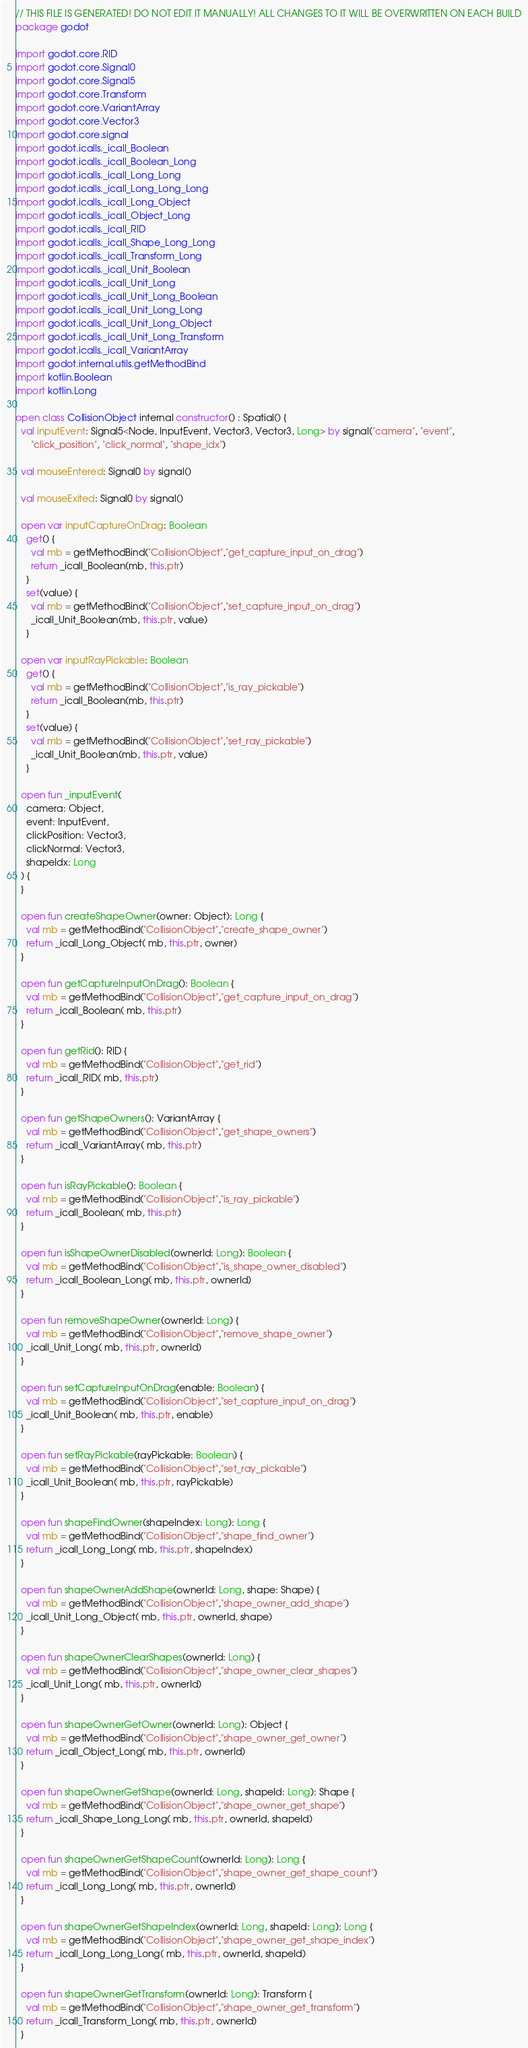Convert code to text. <code><loc_0><loc_0><loc_500><loc_500><_Kotlin_>// THIS FILE IS GENERATED! DO NOT EDIT IT MANUALLY! ALL CHANGES TO IT WILL BE OVERWRITTEN ON EACH BUILD
package godot

import godot.core.RID
import godot.core.Signal0
import godot.core.Signal5
import godot.core.Transform
import godot.core.VariantArray
import godot.core.Vector3
import godot.core.signal
import godot.icalls._icall_Boolean
import godot.icalls._icall_Boolean_Long
import godot.icalls._icall_Long_Long
import godot.icalls._icall_Long_Long_Long
import godot.icalls._icall_Long_Object
import godot.icalls._icall_Object_Long
import godot.icalls._icall_RID
import godot.icalls._icall_Shape_Long_Long
import godot.icalls._icall_Transform_Long
import godot.icalls._icall_Unit_Boolean
import godot.icalls._icall_Unit_Long
import godot.icalls._icall_Unit_Long_Boolean
import godot.icalls._icall_Unit_Long_Long
import godot.icalls._icall_Unit_Long_Object
import godot.icalls._icall_Unit_Long_Transform
import godot.icalls._icall_VariantArray
import godot.internal.utils.getMethodBind
import kotlin.Boolean
import kotlin.Long

open class CollisionObject internal constructor() : Spatial() {
  val inputEvent: Signal5<Node, InputEvent, Vector3, Vector3, Long> by signal("camera", "event",
      "click_position", "click_normal", "shape_idx")

  val mouseEntered: Signal0 by signal()

  val mouseExited: Signal0 by signal()

  open var inputCaptureOnDrag: Boolean
    get() {
      val mb = getMethodBind("CollisionObject","get_capture_input_on_drag")
      return _icall_Boolean(mb, this.ptr)
    }
    set(value) {
      val mb = getMethodBind("CollisionObject","set_capture_input_on_drag")
      _icall_Unit_Boolean(mb, this.ptr, value)
    }

  open var inputRayPickable: Boolean
    get() {
      val mb = getMethodBind("CollisionObject","is_ray_pickable")
      return _icall_Boolean(mb, this.ptr)
    }
    set(value) {
      val mb = getMethodBind("CollisionObject","set_ray_pickable")
      _icall_Unit_Boolean(mb, this.ptr, value)
    }

  open fun _inputEvent(
    camera: Object,
    event: InputEvent,
    clickPosition: Vector3,
    clickNormal: Vector3,
    shapeIdx: Long
  ) {
  }

  open fun createShapeOwner(owner: Object): Long {
    val mb = getMethodBind("CollisionObject","create_shape_owner")
    return _icall_Long_Object( mb, this.ptr, owner)
  }

  open fun getCaptureInputOnDrag(): Boolean {
    val mb = getMethodBind("CollisionObject","get_capture_input_on_drag")
    return _icall_Boolean( mb, this.ptr)
  }

  open fun getRid(): RID {
    val mb = getMethodBind("CollisionObject","get_rid")
    return _icall_RID( mb, this.ptr)
  }

  open fun getShapeOwners(): VariantArray {
    val mb = getMethodBind("CollisionObject","get_shape_owners")
    return _icall_VariantArray( mb, this.ptr)
  }

  open fun isRayPickable(): Boolean {
    val mb = getMethodBind("CollisionObject","is_ray_pickable")
    return _icall_Boolean( mb, this.ptr)
  }

  open fun isShapeOwnerDisabled(ownerId: Long): Boolean {
    val mb = getMethodBind("CollisionObject","is_shape_owner_disabled")
    return _icall_Boolean_Long( mb, this.ptr, ownerId)
  }

  open fun removeShapeOwner(ownerId: Long) {
    val mb = getMethodBind("CollisionObject","remove_shape_owner")
    _icall_Unit_Long( mb, this.ptr, ownerId)
  }

  open fun setCaptureInputOnDrag(enable: Boolean) {
    val mb = getMethodBind("CollisionObject","set_capture_input_on_drag")
    _icall_Unit_Boolean( mb, this.ptr, enable)
  }

  open fun setRayPickable(rayPickable: Boolean) {
    val mb = getMethodBind("CollisionObject","set_ray_pickable")
    _icall_Unit_Boolean( mb, this.ptr, rayPickable)
  }

  open fun shapeFindOwner(shapeIndex: Long): Long {
    val mb = getMethodBind("CollisionObject","shape_find_owner")
    return _icall_Long_Long( mb, this.ptr, shapeIndex)
  }

  open fun shapeOwnerAddShape(ownerId: Long, shape: Shape) {
    val mb = getMethodBind("CollisionObject","shape_owner_add_shape")
    _icall_Unit_Long_Object( mb, this.ptr, ownerId, shape)
  }

  open fun shapeOwnerClearShapes(ownerId: Long) {
    val mb = getMethodBind("CollisionObject","shape_owner_clear_shapes")
    _icall_Unit_Long( mb, this.ptr, ownerId)
  }

  open fun shapeOwnerGetOwner(ownerId: Long): Object {
    val mb = getMethodBind("CollisionObject","shape_owner_get_owner")
    return _icall_Object_Long( mb, this.ptr, ownerId)
  }

  open fun shapeOwnerGetShape(ownerId: Long, shapeId: Long): Shape {
    val mb = getMethodBind("CollisionObject","shape_owner_get_shape")
    return _icall_Shape_Long_Long( mb, this.ptr, ownerId, shapeId)
  }

  open fun shapeOwnerGetShapeCount(ownerId: Long): Long {
    val mb = getMethodBind("CollisionObject","shape_owner_get_shape_count")
    return _icall_Long_Long( mb, this.ptr, ownerId)
  }

  open fun shapeOwnerGetShapeIndex(ownerId: Long, shapeId: Long): Long {
    val mb = getMethodBind("CollisionObject","shape_owner_get_shape_index")
    return _icall_Long_Long_Long( mb, this.ptr, ownerId, shapeId)
  }

  open fun shapeOwnerGetTransform(ownerId: Long): Transform {
    val mb = getMethodBind("CollisionObject","shape_owner_get_transform")
    return _icall_Transform_Long( mb, this.ptr, ownerId)
  }
</code> 